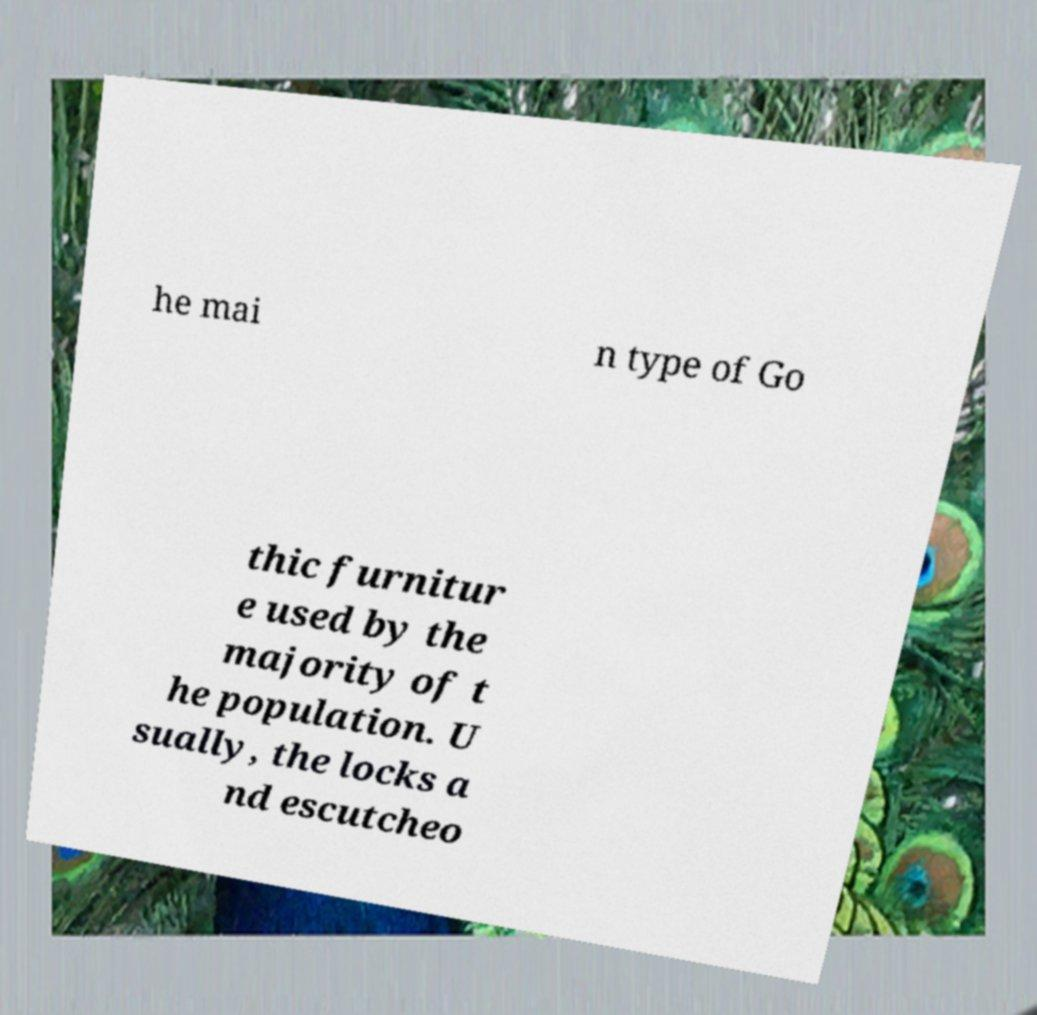I need the written content from this picture converted into text. Can you do that? he mai n type of Go thic furnitur e used by the majority of t he population. U sually, the locks a nd escutcheo 